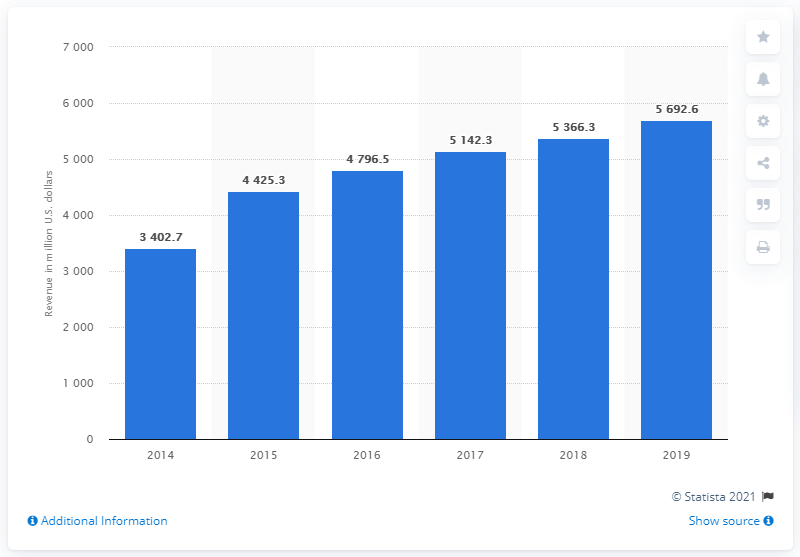Highlight a few significant elements in this photo. In 2019, Cerner Corporation's annual revenue was approximately 5692.6 million dollars. 